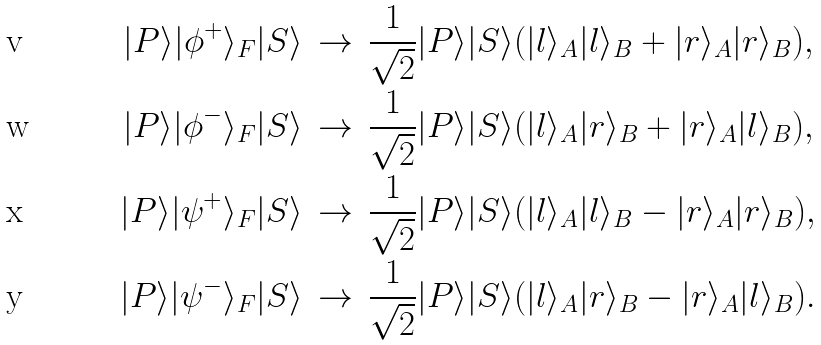<formula> <loc_0><loc_0><loc_500><loc_500>| P \rangle | \phi ^ { + } \rangle _ { F } | S \rangle & \, \rightarrow \, \frac { 1 } { \sqrt { 2 } } | P \rangle | S \rangle ( | l \rangle _ { A } | l \rangle _ { B } + | r \rangle _ { A } | r \rangle _ { B } ) , \\ | P \rangle | \phi ^ { - } \rangle _ { F } | S \rangle & \, \rightarrow \, \frac { 1 } { \sqrt { 2 } } | P \rangle | S \rangle ( | l \rangle _ { A } | r \rangle _ { B } + | r \rangle _ { A } | l \rangle _ { B } ) , \\ | P \rangle | \psi ^ { + } \rangle _ { F } | S \rangle & \, \rightarrow \, \frac { 1 } { \sqrt { 2 } } | P \rangle | S \rangle ( | l \rangle _ { A } | l \rangle _ { B } - | r \rangle _ { A } | r \rangle _ { B } ) , \\ | P \rangle | \psi ^ { - } \rangle _ { F } | S \rangle & \, \rightarrow \, \frac { 1 } { \sqrt { 2 } } | P \rangle | S \rangle ( | l \rangle _ { A } | r \rangle _ { B } - | r \rangle _ { A } | l \rangle _ { B } ) .</formula> 